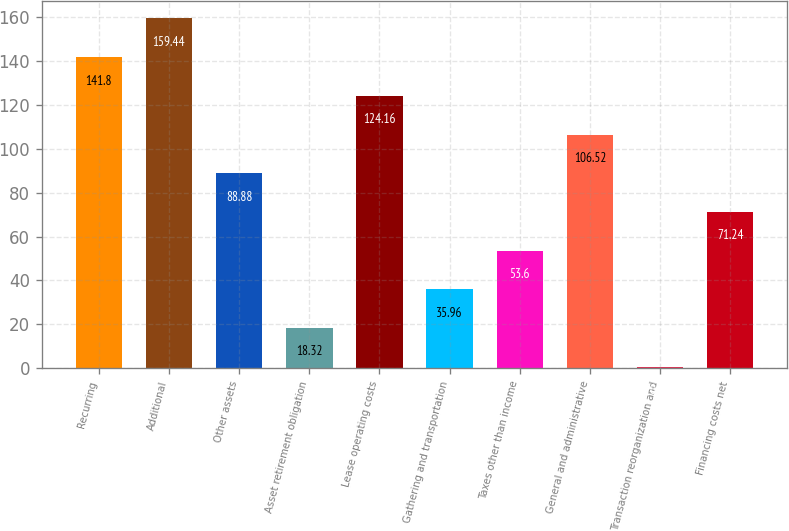Convert chart to OTSL. <chart><loc_0><loc_0><loc_500><loc_500><bar_chart><fcel>Recurring<fcel>Additional<fcel>Other assets<fcel>Asset retirement obligation<fcel>Lease operating costs<fcel>Gathering and transportation<fcel>Taxes other than income<fcel>General and administrative<fcel>Transaction reorganization and<fcel>Financing costs net<nl><fcel>141.8<fcel>159.44<fcel>88.88<fcel>18.32<fcel>124.16<fcel>35.96<fcel>53.6<fcel>106.52<fcel>0.68<fcel>71.24<nl></chart> 